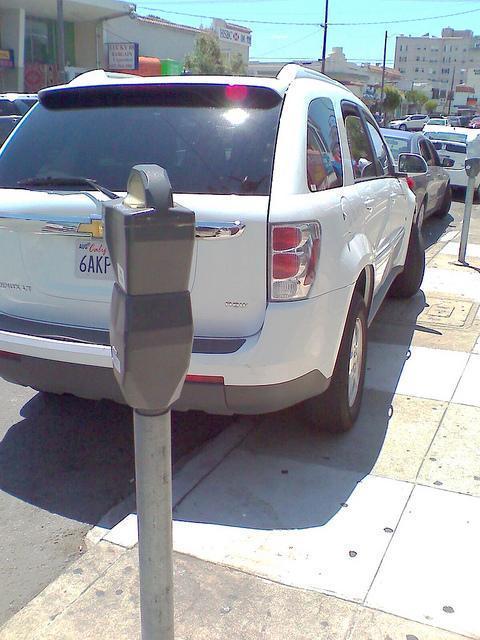How many cars are there?
Give a very brief answer. 3. How many girls are talking on cell phones?
Give a very brief answer. 0. 